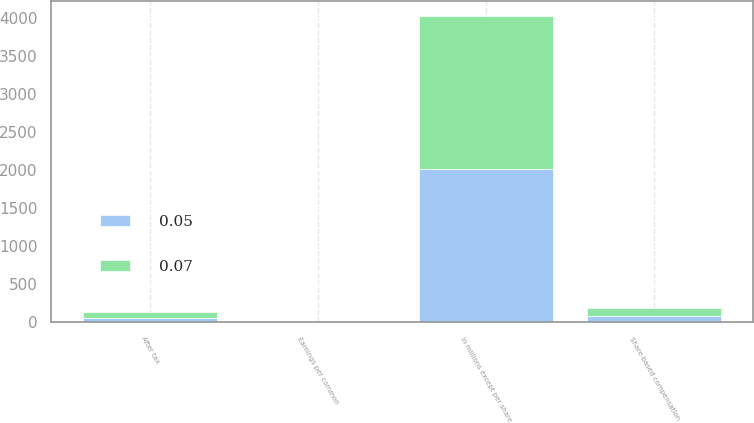<chart> <loc_0><loc_0><loc_500><loc_500><stacked_bar_chart><ecel><fcel>In millions except per share<fcel>Share-based compensation<fcel>After tax<fcel>Earnings per common<nl><fcel>0.05<fcel>2010<fcel>83.1<fcel>56.2<fcel>0.05<nl><fcel>0.07<fcel>2009<fcel>112.9<fcel>76.1<fcel>0.07<nl></chart> 